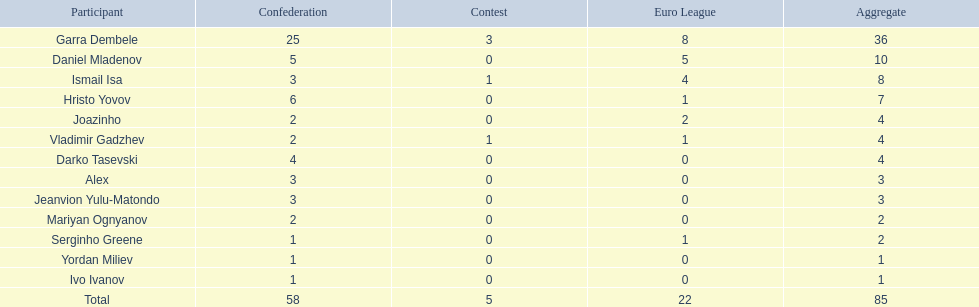Which player is in the same league as joazinho and vladimir gadzhev? Mariyan Ognyanov. 